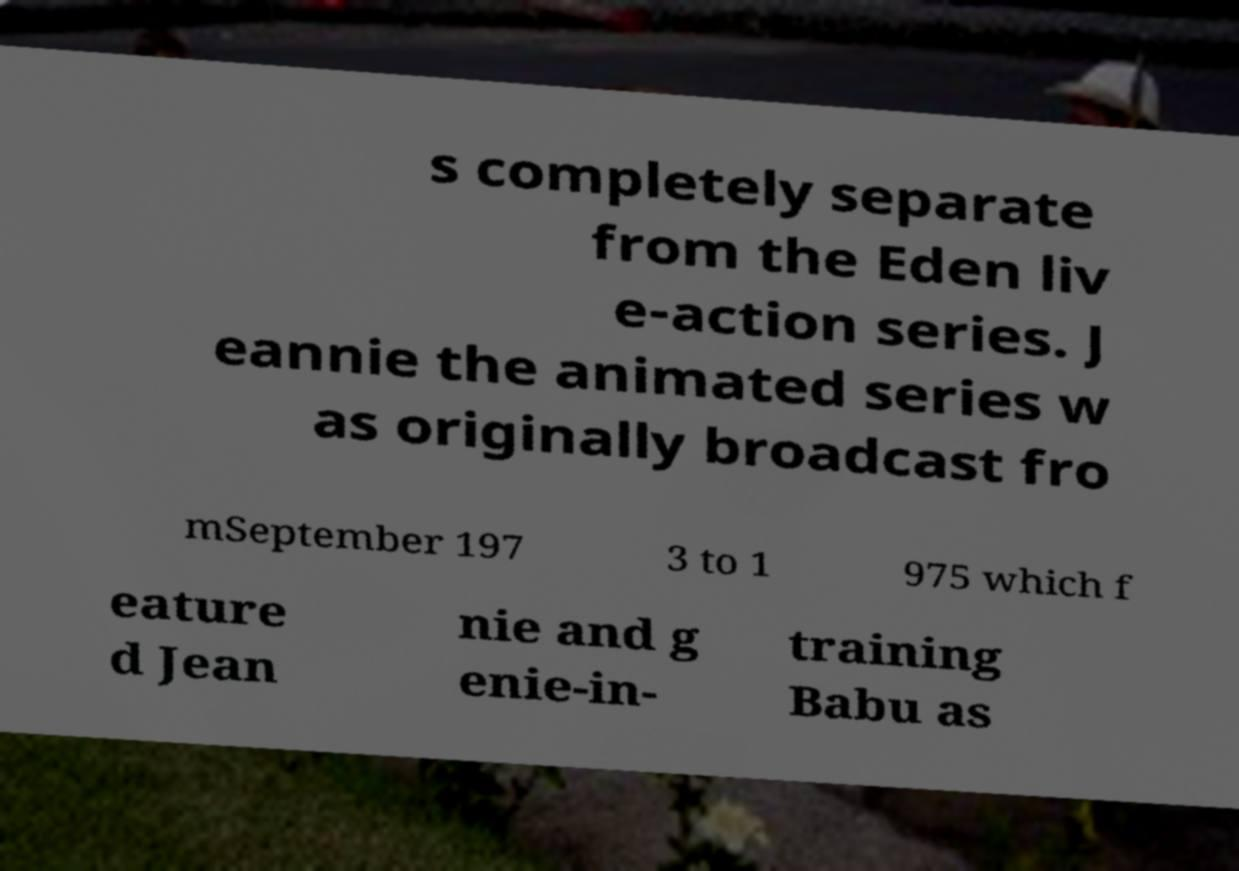For documentation purposes, I need the text within this image transcribed. Could you provide that? s completely separate from the Eden liv e-action series. J eannie the animated series w as originally broadcast fro mSeptember 197 3 to 1 975 which f eature d Jean nie and g enie-in- training Babu as 